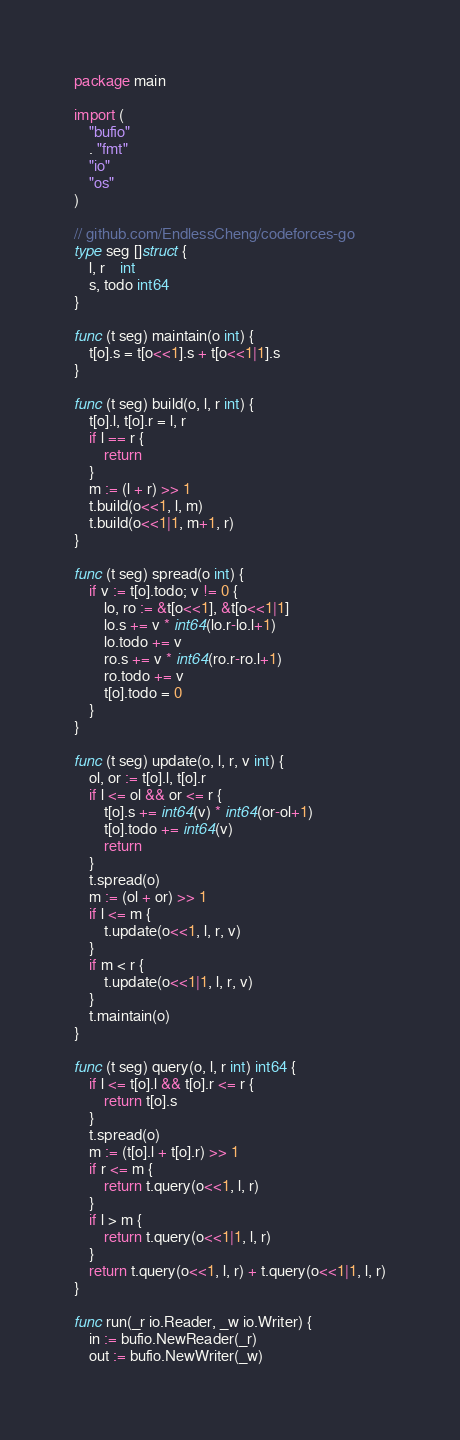Convert code to text. <code><loc_0><loc_0><loc_500><loc_500><_Go_>package main

import (
	"bufio"
	. "fmt"
	"io"
	"os"
)

// github.com/EndlessCheng/codeforces-go
type seg []struct {
	l, r    int
	s, todo int64
}

func (t seg) maintain(o int) {
	t[o].s = t[o<<1].s + t[o<<1|1].s
}

func (t seg) build(o, l, r int) {
	t[o].l, t[o].r = l, r
	if l == r {
		return
	}
	m := (l + r) >> 1
	t.build(o<<1, l, m)
	t.build(o<<1|1, m+1, r)
}

func (t seg) spread(o int) {
	if v := t[o].todo; v != 0 {
		lo, ro := &t[o<<1], &t[o<<1|1]
		lo.s += v * int64(lo.r-lo.l+1)
		lo.todo += v
		ro.s += v * int64(ro.r-ro.l+1)
		ro.todo += v
		t[o].todo = 0
	}
}

func (t seg) update(o, l, r, v int) {
	ol, or := t[o].l, t[o].r
	if l <= ol && or <= r {
		t[o].s += int64(v) * int64(or-ol+1)
		t[o].todo += int64(v)
		return
	}
	t.spread(o)
	m := (ol + or) >> 1
	if l <= m {
		t.update(o<<1, l, r, v)
	}
	if m < r {
		t.update(o<<1|1, l, r, v)
	}
	t.maintain(o)
}

func (t seg) query(o, l, r int) int64 {
	if l <= t[o].l && t[o].r <= r {
		return t[o].s
	}
	t.spread(o)
	m := (t[o].l + t[o].r) >> 1
	if r <= m {
		return t.query(o<<1, l, r)
	}
	if l > m {
		return t.query(o<<1|1, l, r)
	}
	return t.query(o<<1, l, r) + t.query(o<<1|1, l, r)
}

func run(_r io.Reader, _w io.Writer) {
	in := bufio.NewReader(_r)
	out := bufio.NewWriter(_w)</code> 